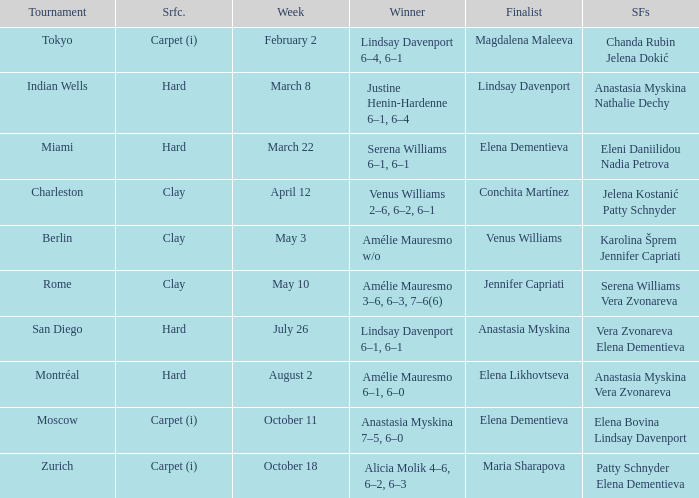Who was the finalist of the hard surface tournament in Miami? Elena Dementieva. 